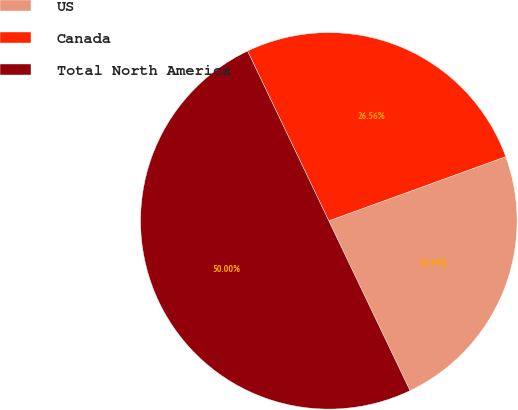Convert chart. <chart><loc_0><loc_0><loc_500><loc_500><pie_chart><fcel>US<fcel>Canada<fcel>Total North America<nl><fcel>23.44%<fcel>26.56%<fcel>50.0%<nl></chart> 